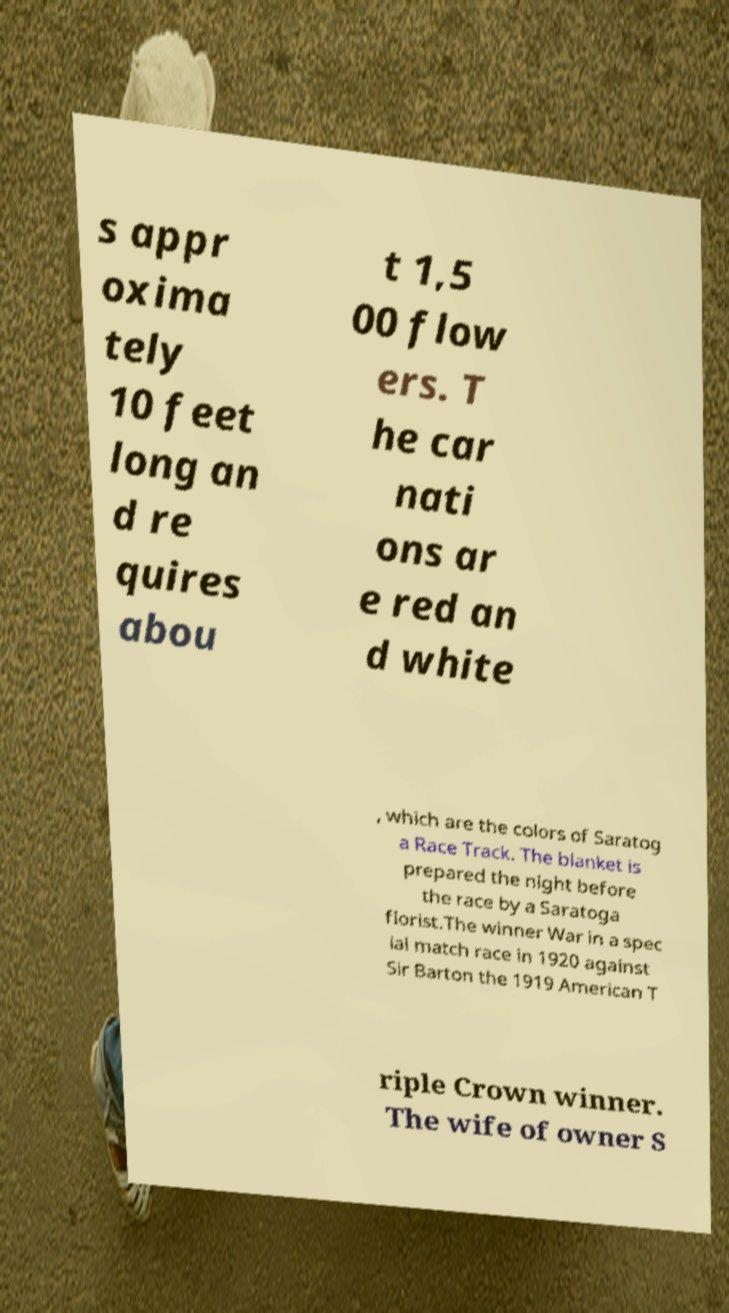I need the written content from this picture converted into text. Can you do that? s appr oxima tely 10 feet long an d re quires abou t 1,5 00 flow ers. T he car nati ons ar e red an d white , which are the colors of Saratog a Race Track. The blanket is prepared the night before the race by a Saratoga florist.The winner War in a spec ial match race in 1920 against Sir Barton the 1919 American T riple Crown winner. The wife of owner S 